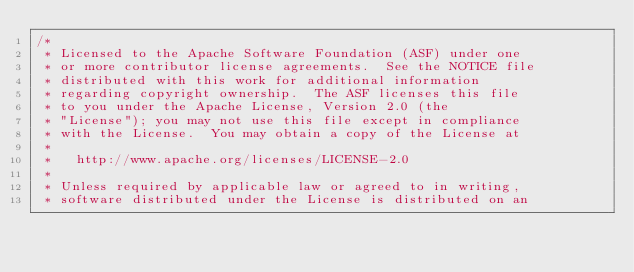Convert code to text. <code><loc_0><loc_0><loc_500><loc_500><_Java_>/*
 * Licensed to the Apache Software Foundation (ASF) under one
 * or more contributor license agreements.  See the NOTICE file
 * distributed with this work for additional information
 * regarding copyright ownership.  The ASF licenses this file
 * to you under the Apache License, Version 2.0 (the
 * "License"); you may not use this file except in compliance
 * with the License.  You may obtain a copy of the License at
 *
 *   http://www.apache.org/licenses/LICENSE-2.0
 *
 * Unless required by applicable law or agreed to in writing,
 * software distributed under the License is distributed on an</code> 